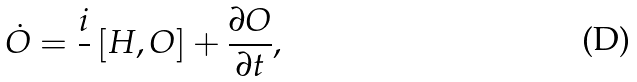Convert formula to latex. <formula><loc_0><loc_0><loc_500><loc_500>\dot { O } = \frac { i } { } \left [ H , O \right ] + \frac { \partial O } { \partial t } ,</formula> 